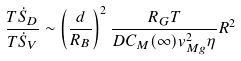Convert formula to latex. <formula><loc_0><loc_0><loc_500><loc_500>\frac { T \dot { S } _ { D } } { T \dot { S } _ { V } } \sim \left ( \frac { d } { R _ { B } } \right ) ^ { 2 } \frac { R _ { G } T } { D C _ { M } ( \infty ) v _ { M g } ^ { 2 } \eta } R ^ { 2 }</formula> 